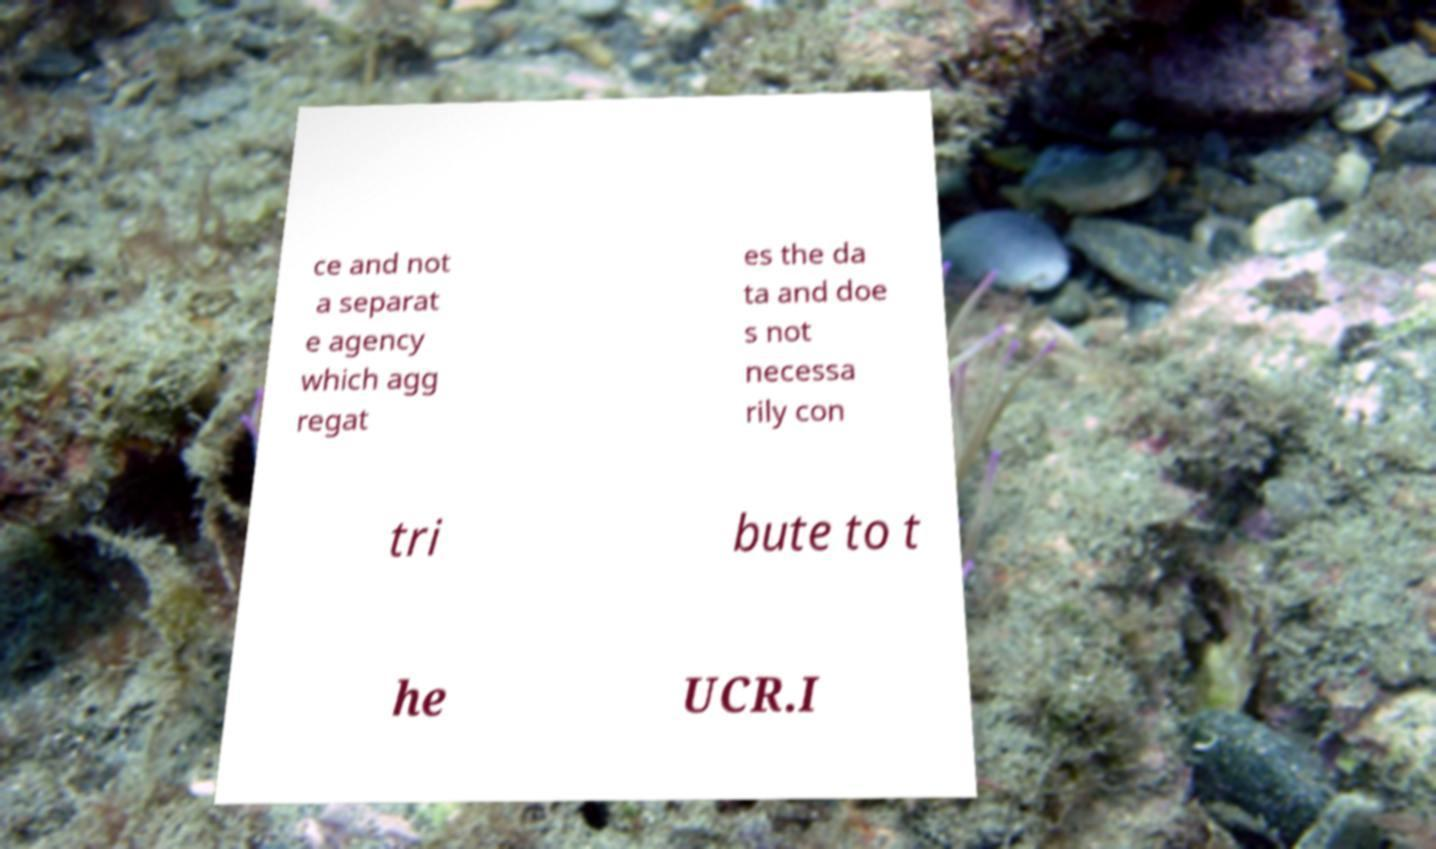Can you read and provide the text displayed in the image?This photo seems to have some interesting text. Can you extract and type it out for me? ce and not a separat e agency which agg regat es the da ta and doe s not necessa rily con tri bute to t he UCR.I 